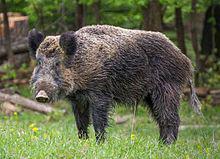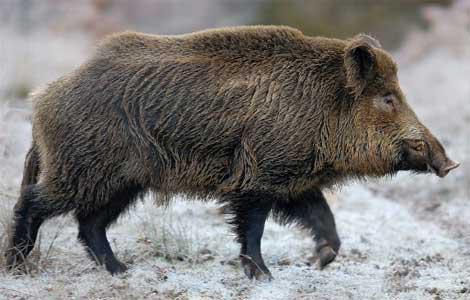The first image is the image on the left, the second image is the image on the right. Examine the images to the left and right. Is the description "There are at least two baby boars in one of the images." accurate? Answer yes or no. No. 